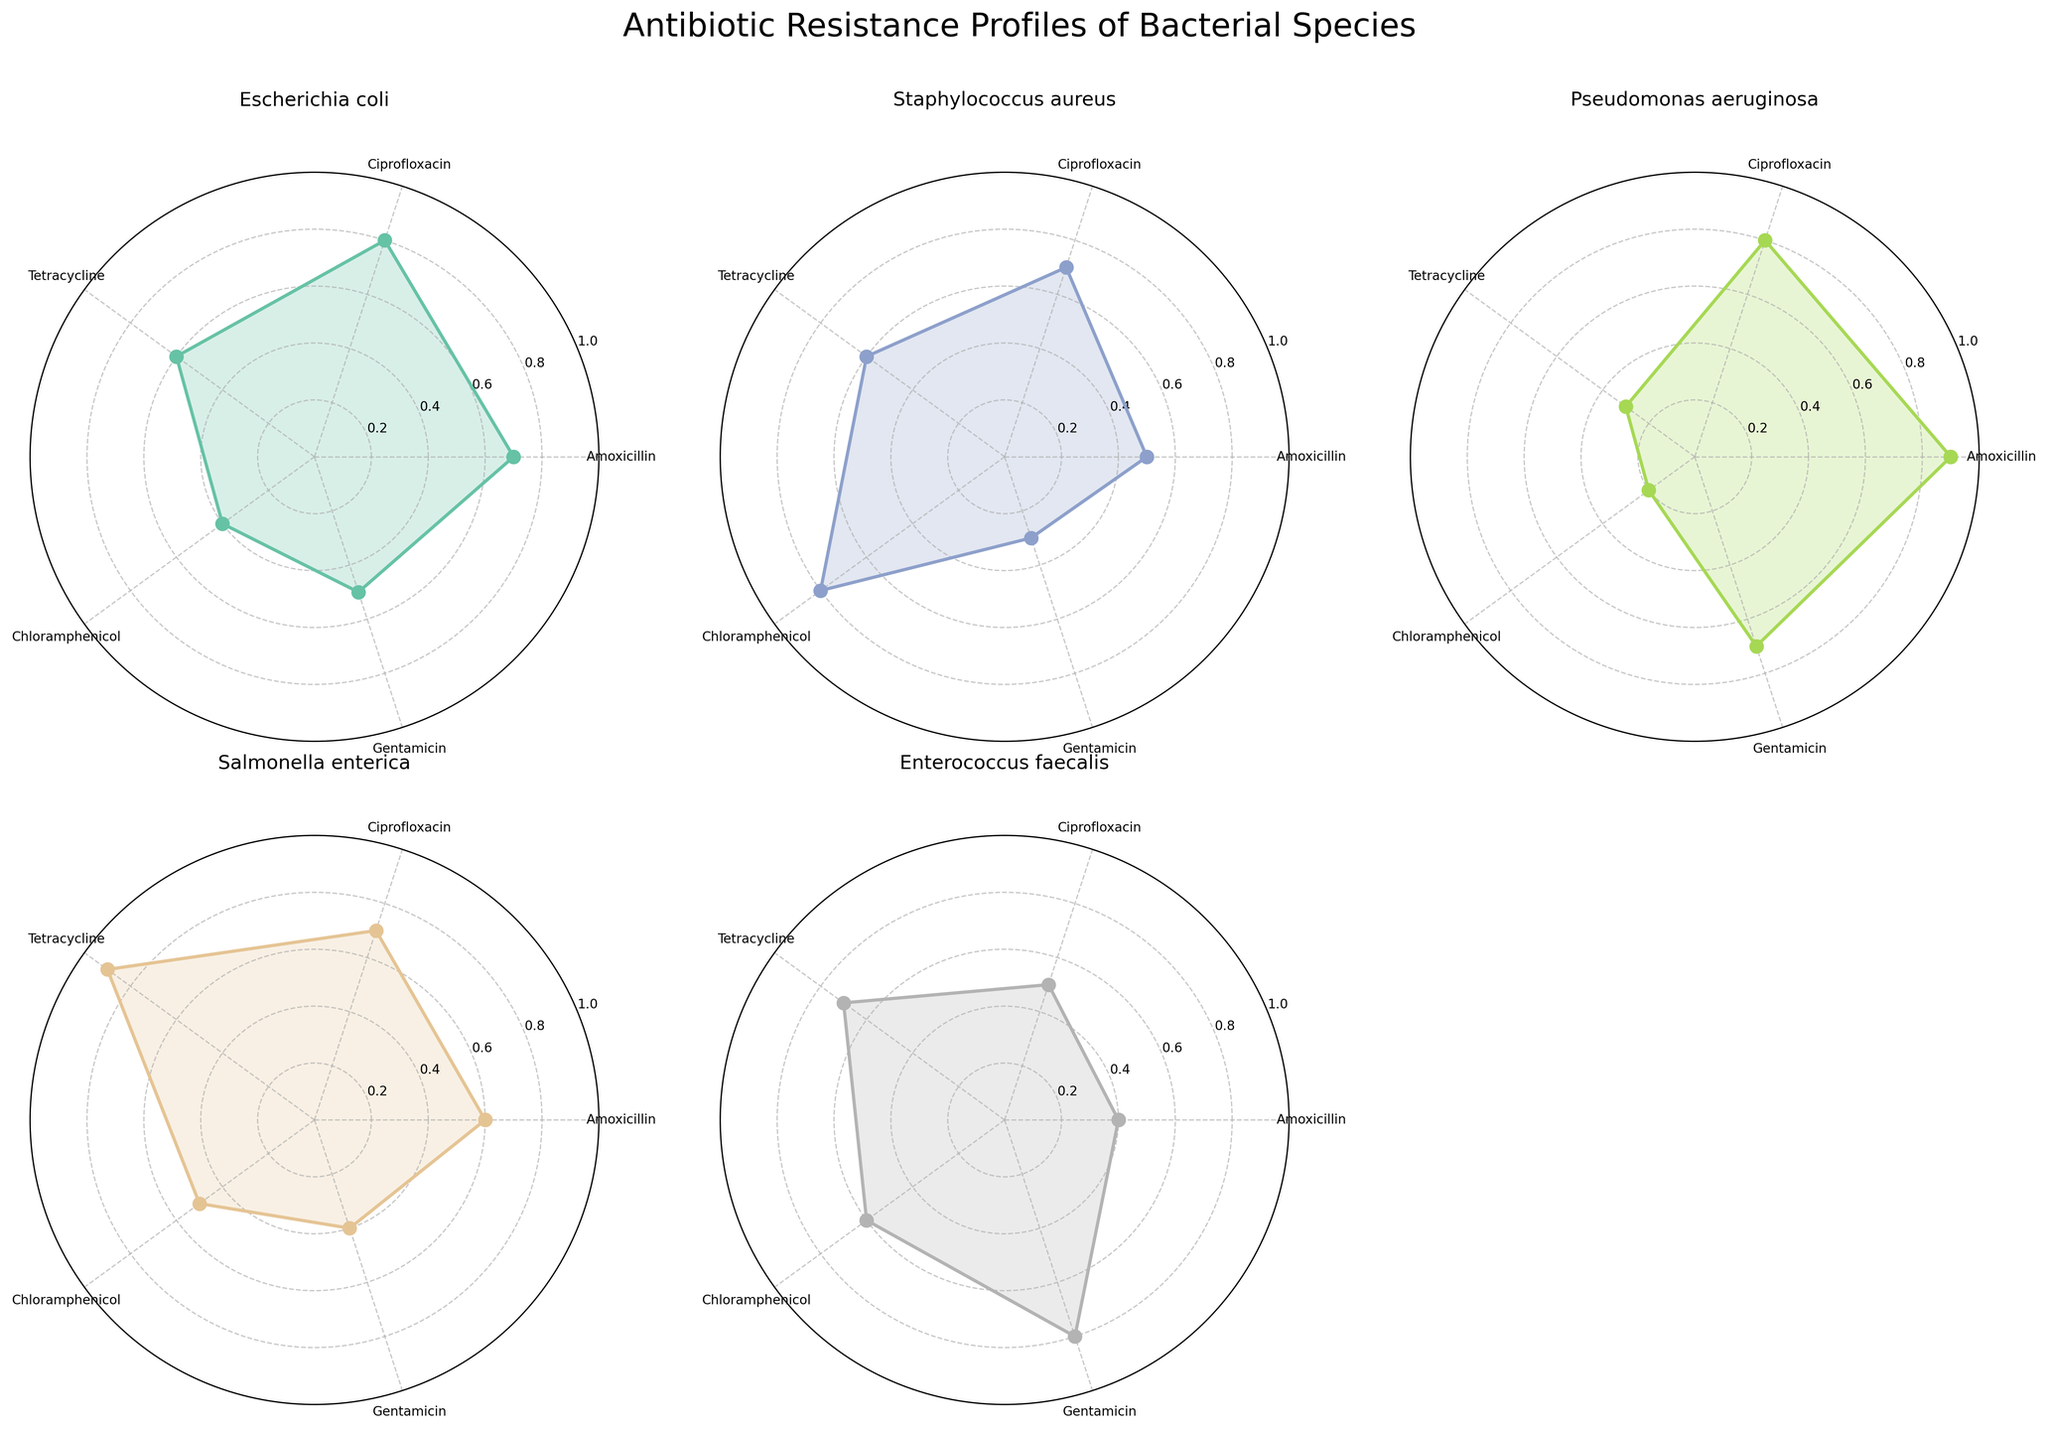What's the title of the figure? The figure's title is typically displayed at the top. In this case, you can read it directly from the plot.
Answer: Antibiotic Resistance Profiles of Bacterial Species How many antibiotics are being tested across bacterial species? To find the number of antibiotics tested, count the distinct labels on the axes of any radar chart subplot. In this case, there are 5 antibiotics.
Answer: 5 Which bacterial species shows the highest resistance to Amoxicillin? Look at the Amoxicillin axonal segment in each subplot and compare the values. Pseudomonas aeruginosa shows the highest resistance level to Amoxicillin.
Answer: Pseudomonas aeruginosa Which bacterial species has the lowest overall resistance profile? Observe which radar chart has the smallest areas filled across all antibiotics. In this plot, Enterococcus faecalis has the smallest overall radar chart area.
Answer: Enterococcus faecalis Among Escherichia coli and Staphylococcus aureus, which one shows higher resistance to Ciprofloxacin? Compare the resistance levels to Ciprofloxacin in the subplots for Escherichia coli and Staphylococcus aureus. Escherichia coli has a resistance level of 0.8, while Staphylococcus aureus has a resistance level of 0.7.
Answer: Escherichia coli Which antibiotic does Salmonella enterica show the highest resistance to? Check the radar chart for Salmonella enterica and identify the highest resistance value. The highest value is shown for Tetracycline.
Answer: Tetracycline Considering only Gentamicin resistance levels, which bacterial species has the highest resistance? Examine the Gentamicin segment in each subplot and find the bacterial species with the greatest value. Enterococcus faecalis shows the highest resistance level at 0.8.
Answer: Enterococcus faecalis What is the average resistance level of Pseudomonas aeruginosa across all antibiotics? Sum up the resistance levels for Pseudomonas aeruginosa (0.9, 0.8, 0.3, 0.2, 0.7) and divide by the number of antibiotics, which is 5. The average is (0.9 + 0.8 + 0.3 + 0.2 + 0.7)/5 = 0.58.
Answer: 0.58 Which antibiotic shows the highest average resistance across all bacterial species? To determine this, add the resistance levels for each antibiotic across all subplots and then average them. For example, the average resistance for Amoxicillin is (0.7 + 0.5 + 0.9 + 0.6 + 0.4)/5 = 0.62. Similarly calculate for other antibiotics and compare. The highest average is for Ciprofloxacin at 0.7.
Answer: Ciprofloxacin 